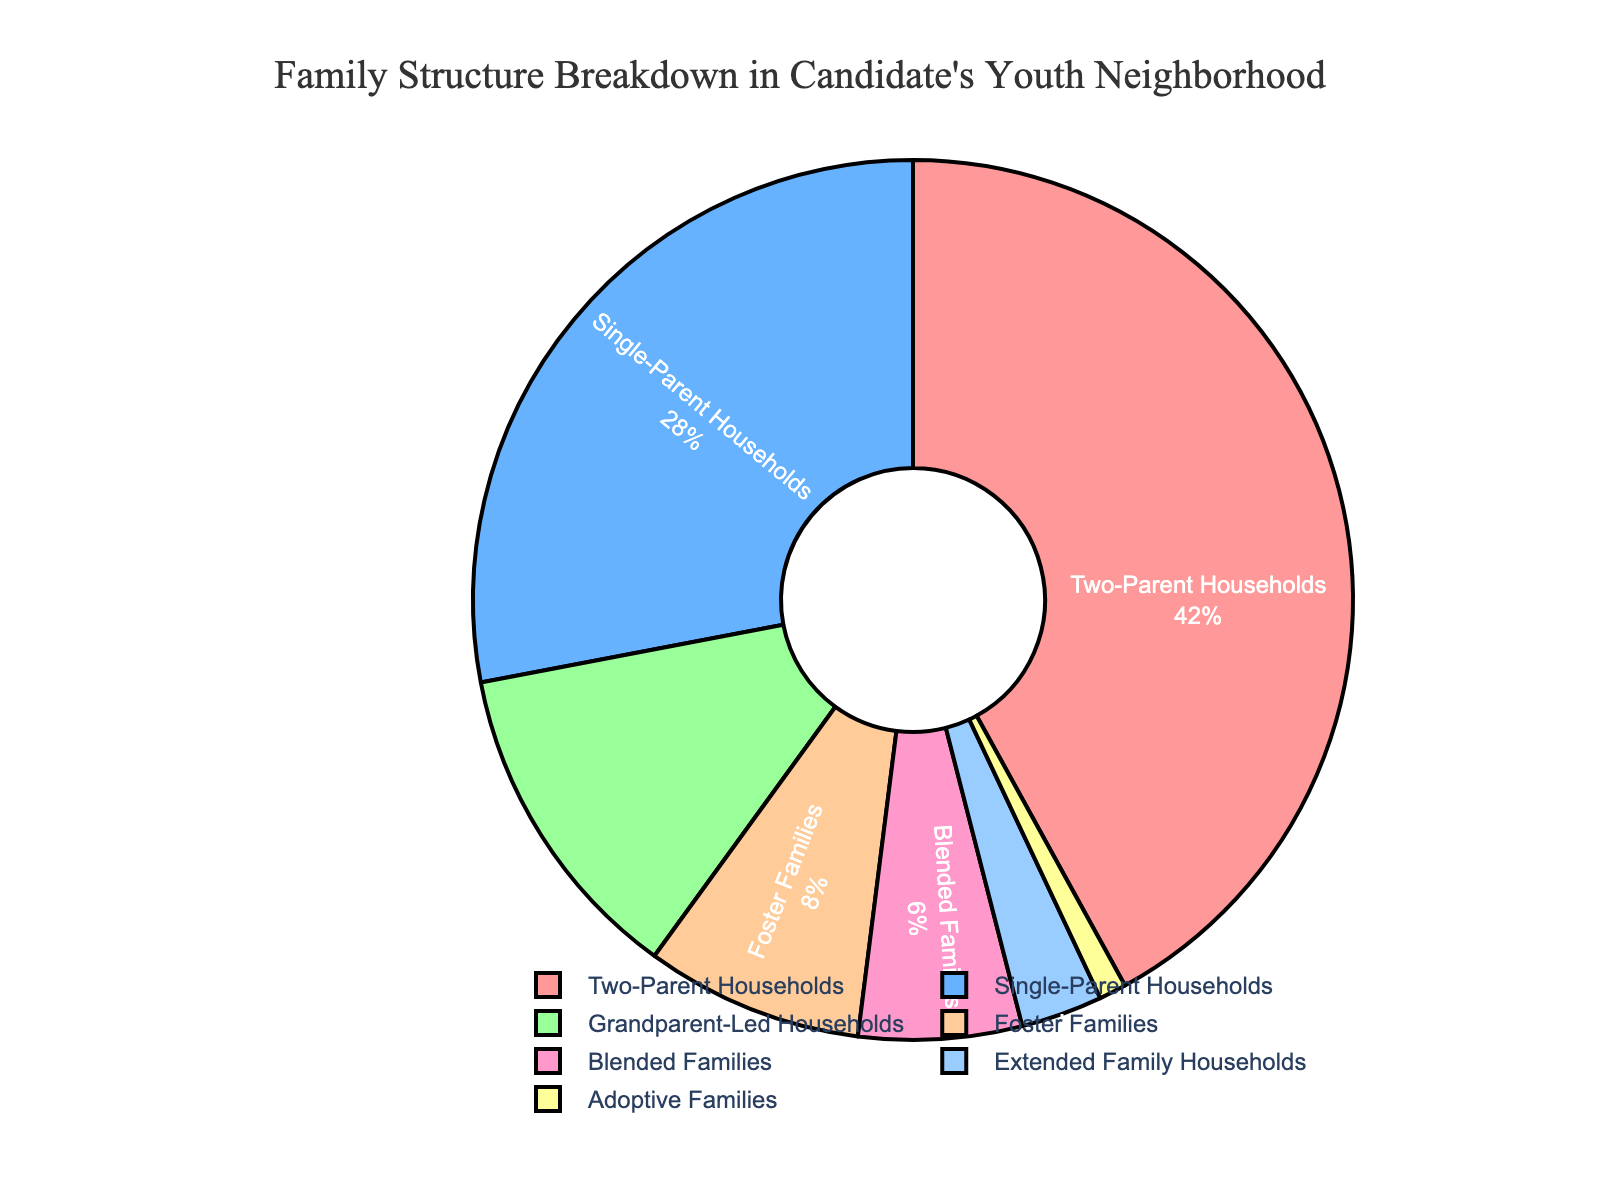What is the most common family structure in the candidate's neighborhood during their youth? The figure shows the percentage breakdown of various family structures, and the largest segment will represent the most common type. The "Two-Parent Households" segment is the largest at 42%.
Answer: Two-Parent Households What is the combined percentage of Grandparent-Led Households and Foster Families? To find the combined percentage, add the percentages of "Grandparent-Led Households" (12%) and "Foster Families" (8%). 12% + 8% = 20%.
Answer: 20% How does the percentage of Single-Parent Households compare to Blended Families? Compare the percentages shown for "Single-Parent Households" (28%) and "Blended Families" (6%). 28% is greater than 6%.
Answer: Single-Parent Households are greater Which family structure category is represented by the smallest segment? Evaluate the segments by size, the smallest percentage is "Adoptive Families" which is 1%.
Answer: Adoptive Families What's the difference in percentage between Two-Parent Households and Extended Family Households? The percentage for "Two-Parent Households" is 42% and for "Extended Family Households" is 3%. The difference is 42% - 3% = 39%.
Answer: 39% What percentage of households are either Foster Families or Blended Families? Add the percentages of "Foster Families" (8%) and "Blended Families" (6%). 8% + 6% = 14%.
Answer: 14% What are the three most common family structures shown in the pie chart? Identify the three segments with the highest percentages: "Two-Parent Households" (42%), "Single-Parent Households" (28%), and "Grandparent-Led Households" (12%).
Answer: Two-Parent Households, Single-Parent Households, Grandparent-Led Households How many family structures have a percentage greater than 10%? Count the segments with percentages greater than 10%: "Two-Parent Households" (42%), "Single-Parent Households" (28%), and "Grandparent-Led Households" (12%).
Answer: 3 In terms of visual attributes, what color represents Foster Families? Identify the segment color associated with "Foster Families" using the legend on the plot. The color for "Foster Families" is shown in a light orange shade.
Answer: Light orange If we combine Adoptive Families and Extended Family Households, what is their total percentage and how does it compare to Grandparent-Led Households? The combined percentage is the sum of "Adoptive Families" (1%) and "Extended Family Households" (3%), giving 4%. Compare it to "Grandparent-Led Households" (12%). 12% is greater than 4%.
Answer: 4% and less than Grandparent-Led Households 